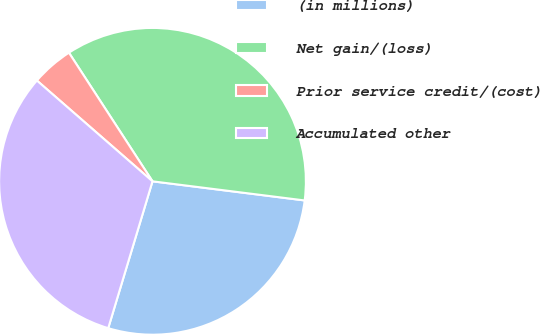Convert chart to OTSL. <chart><loc_0><loc_0><loc_500><loc_500><pie_chart><fcel>(in millions)<fcel>Net gain/(loss)<fcel>Prior service credit/(cost)<fcel>Accumulated other<nl><fcel>27.67%<fcel>36.16%<fcel>4.42%<fcel>31.75%<nl></chart> 